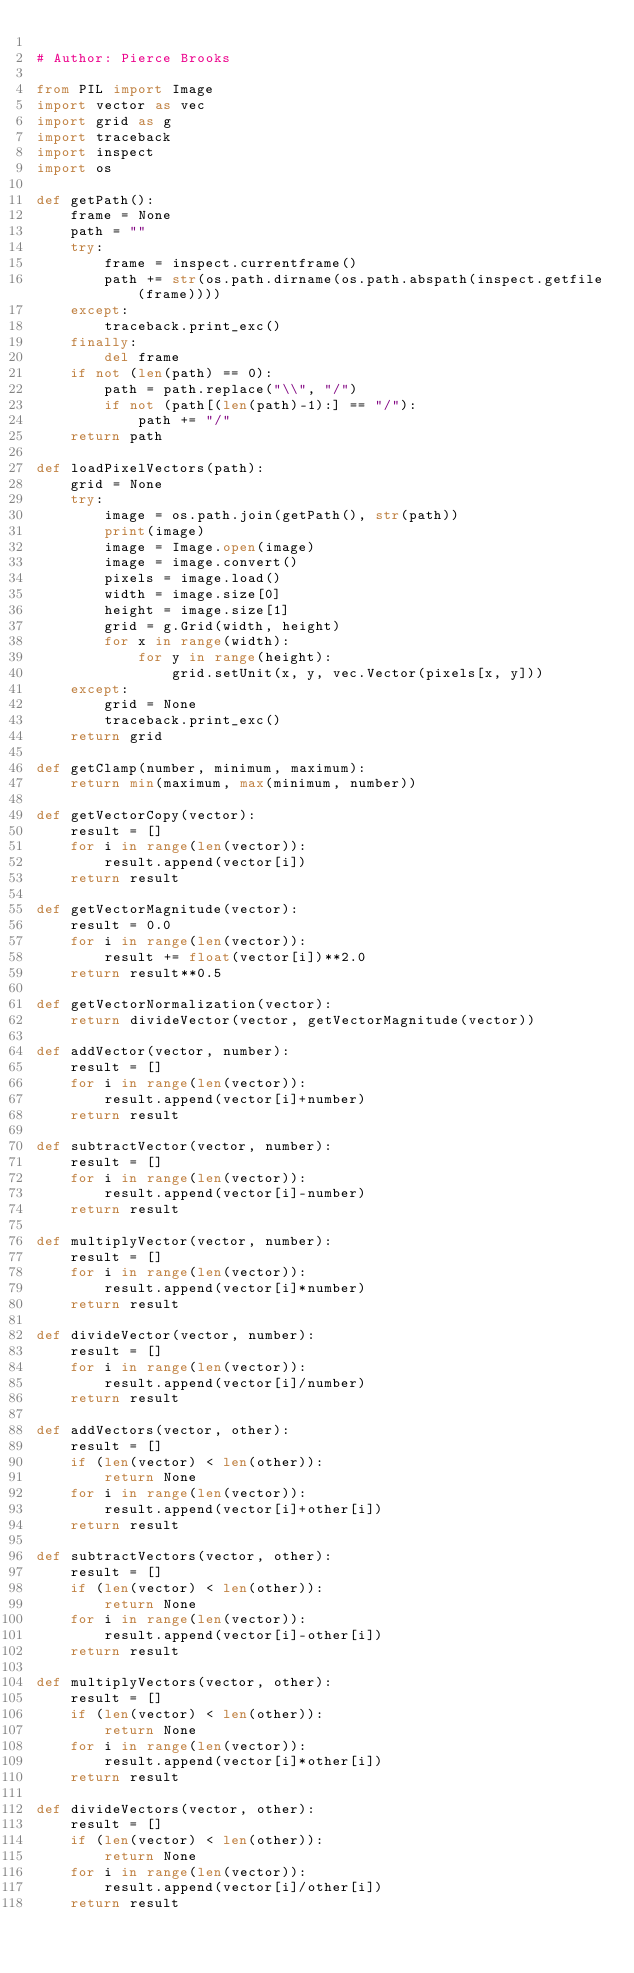Convert code to text. <code><loc_0><loc_0><loc_500><loc_500><_Python_>
# Author: Pierce Brooks

from PIL import Image
import vector as vec
import grid as g
import traceback
import inspect
import os

def getPath():
    frame = None
    path = ""
    try:
        frame = inspect.currentframe()
        path += str(os.path.dirname(os.path.abspath(inspect.getfile(frame))))
    except:
        traceback.print_exc()
    finally:
        del frame
    if not (len(path) == 0):
        path = path.replace("\\", "/")
        if not (path[(len(path)-1):] == "/"):
            path += "/"
	return path

def loadPixelVectors(path):
    grid = None
    try:
        image = os.path.join(getPath(), str(path))
        print(image)
        image = Image.open(image)
        image = image.convert()
        pixels = image.load()
        width = image.size[0]
        height = image.size[1]
        grid = g.Grid(width, height)
        for x in range(width):
            for y in range(height):
                grid.setUnit(x, y, vec.Vector(pixels[x, y]))
    except:
        grid = None
        traceback.print_exc()
    return grid

def getClamp(number, minimum, maximum):
    return min(maximum, max(minimum, number))

def getVectorCopy(vector):
	result = []
	for i in range(len(vector)):
		result.append(vector[i])
	return result

def getVectorMagnitude(vector):
    result = 0.0
    for i in range(len(vector)):
        result += float(vector[i])**2.0
    return result**0.5

def getVectorNormalization(vector):
    return divideVector(vector, getVectorMagnitude(vector))

def addVector(vector, number):
	result = []
	for i in range(len(vector)):
		result.append(vector[i]+number)
	return result

def subtractVector(vector, number):
	result = []
	for i in range(len(vector)):
		result.append(vector[i]-number)
	return result

def multiplyVector(vector, number):
	result = []
	for i in range(len(vector)):
		result.append(vector[i]*number)
	return result

def divideVector(vector, number):
	result = []
	for i in range(len(vector)):
		result.append(vector[i]/number)
	return result

def addVectors(vector, other):
	result = []
	if (len(vector) < len(other)):
		return None
	for i in range(len(vector)):
		result.append(vector[i]+other[i])
	return result

def subtractVectors(vector, other):
	result = []
	if (len(vector) < len(other)):
		return None
	for i in range(len(vector)):
		result.append(vector[i]-other[i])
	return result

def multiplyVectors(vector, other):
	result = []
	if (len(vector) < len(other)):
		return None
	for i in range(len(vector)):
		result.append(vector[i]*other[i])
	return result

def divideVectors(vector, other):
	result = []
	if (len(vector) < len(other)):
		return None
	for i in range(len(vector)):
		result.append(vector[i]/other[i])
	return result
</code> 